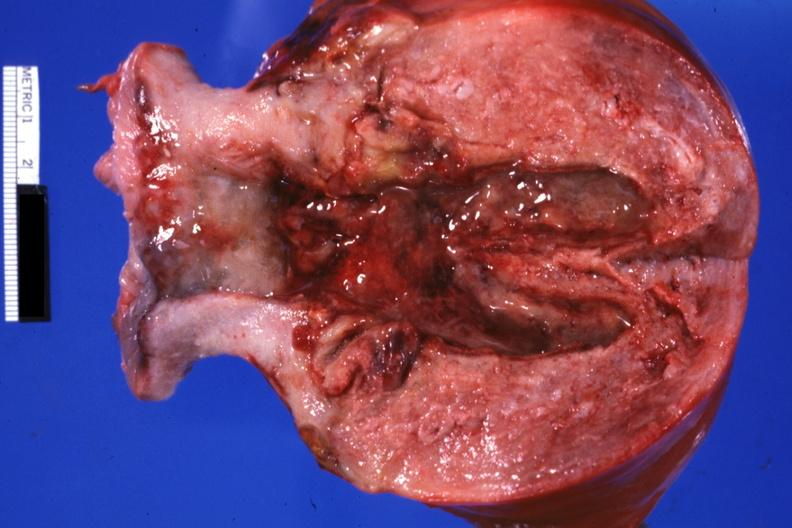s malignant lymphoma present?
Answer the question using a single word or phrase. No 